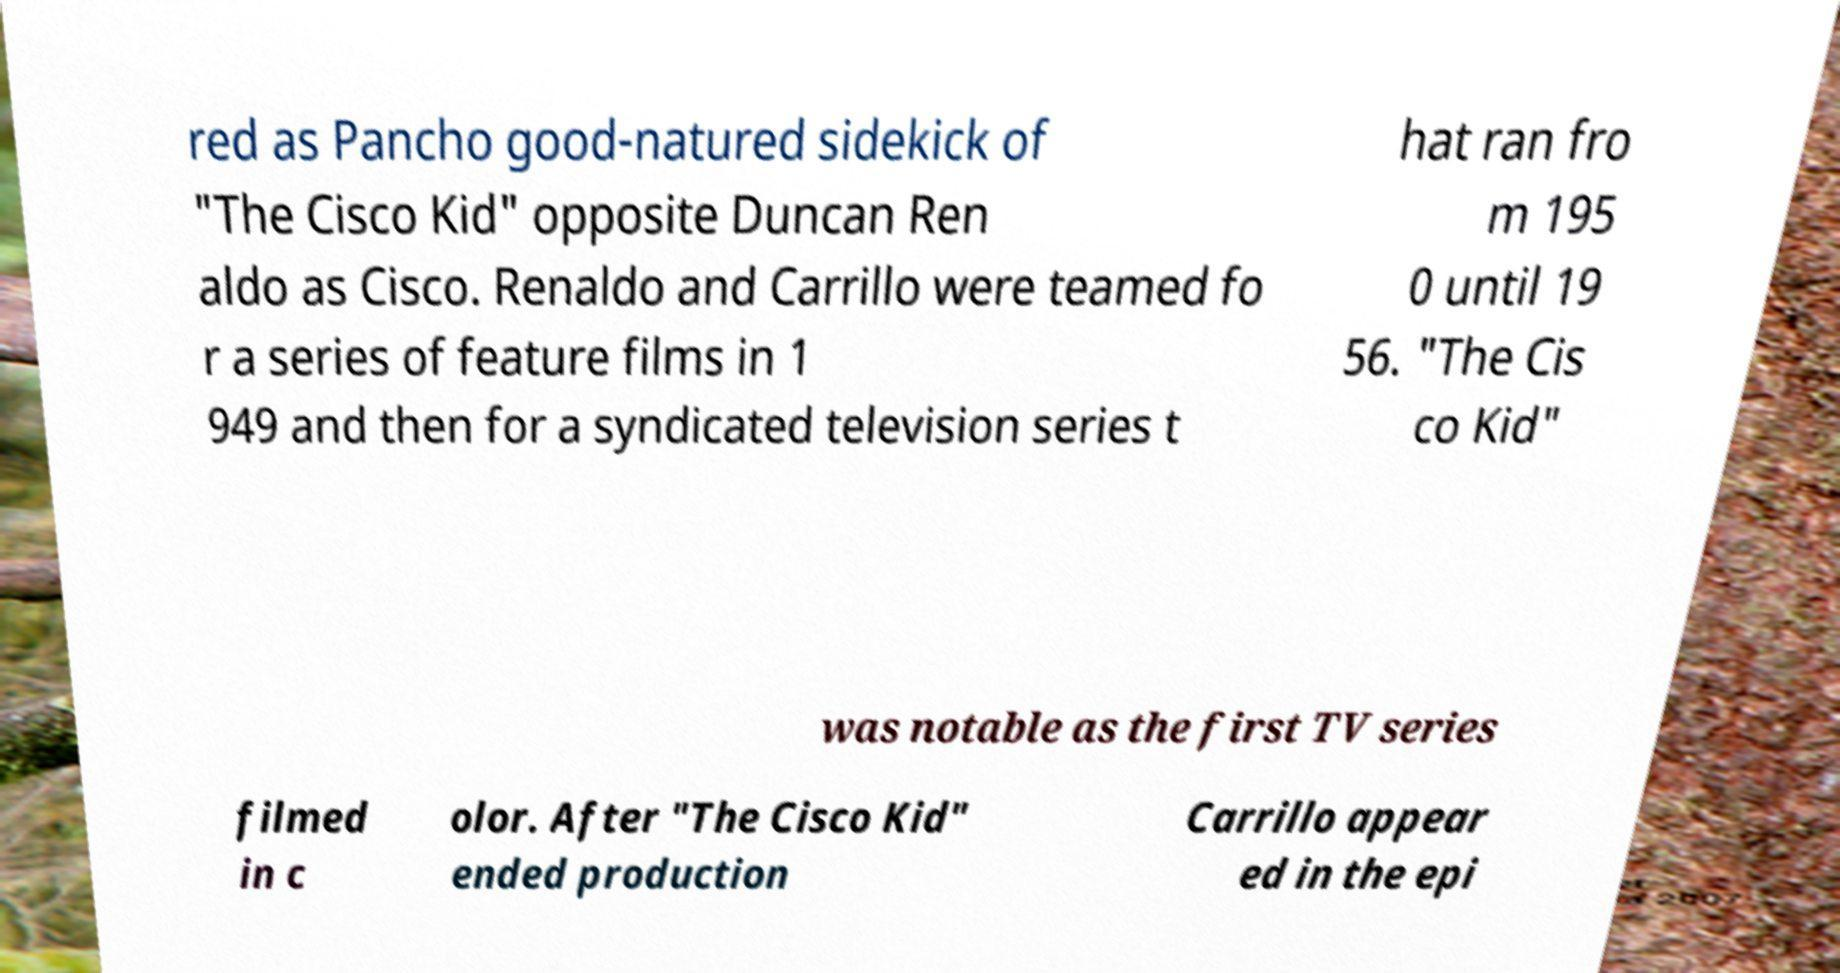I need the written content from this picture converted into text. Can you do that? red as Pancho good-natured sidekick of "The Cisco Kid" opposite Duncan Ren aldo as Cisco. Renaldo and Carrillo were teamed fo r a series of feature films in 1 949 and then for a syndicated television series t hat ran fro m 195 0 until 19 56. "The Cis co Kid" was notable as the first TV series filmed in c olor. After "The Cisco Kid" ended production Carrillo appear ed in the epi 